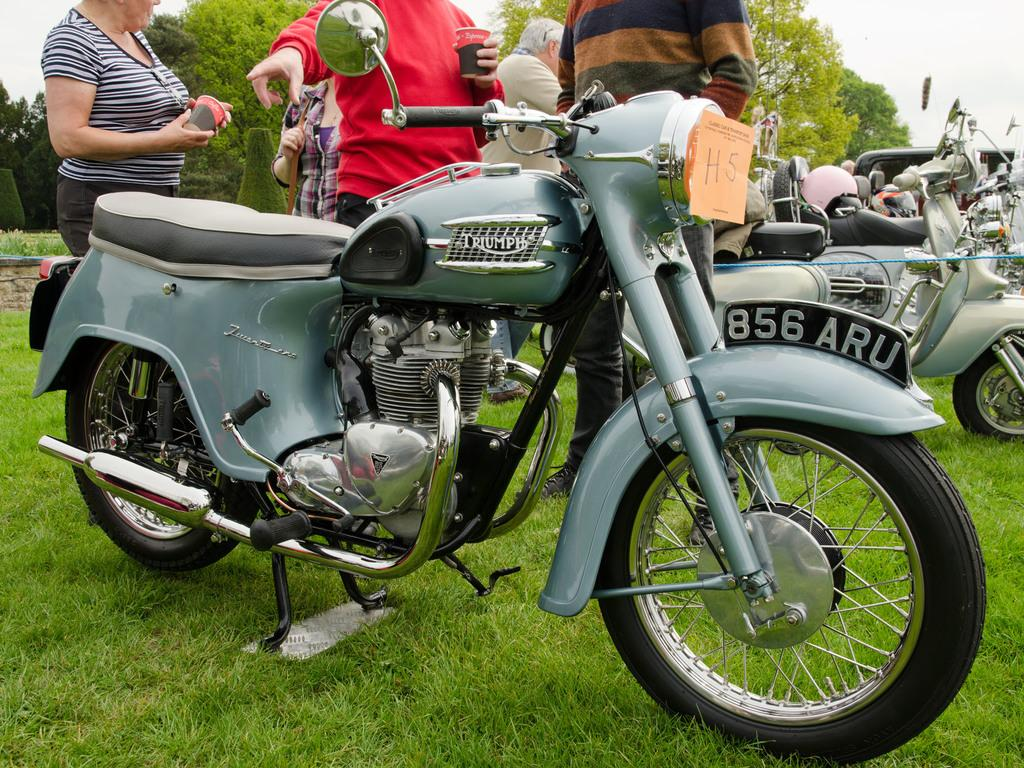What can be seen parked in the image? There are vehicles parked in the image. Are there any people present in the image? Yes, there are people in the image. What can be seen in the background of the image? There are trees and a clear sky in the background of the image. How many socks are visible on the trees in the image? There are no socks visible on the trees in the image. What type of pizzas are being served to the people in the image? There are no pizzas present in the image. 